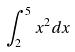Convert formula to latex. <formula><loc_0><loc_0><loc_500><loc_500>\int _ { 2 } ^ { 5 } x ^ { 2 } d x</formula> 